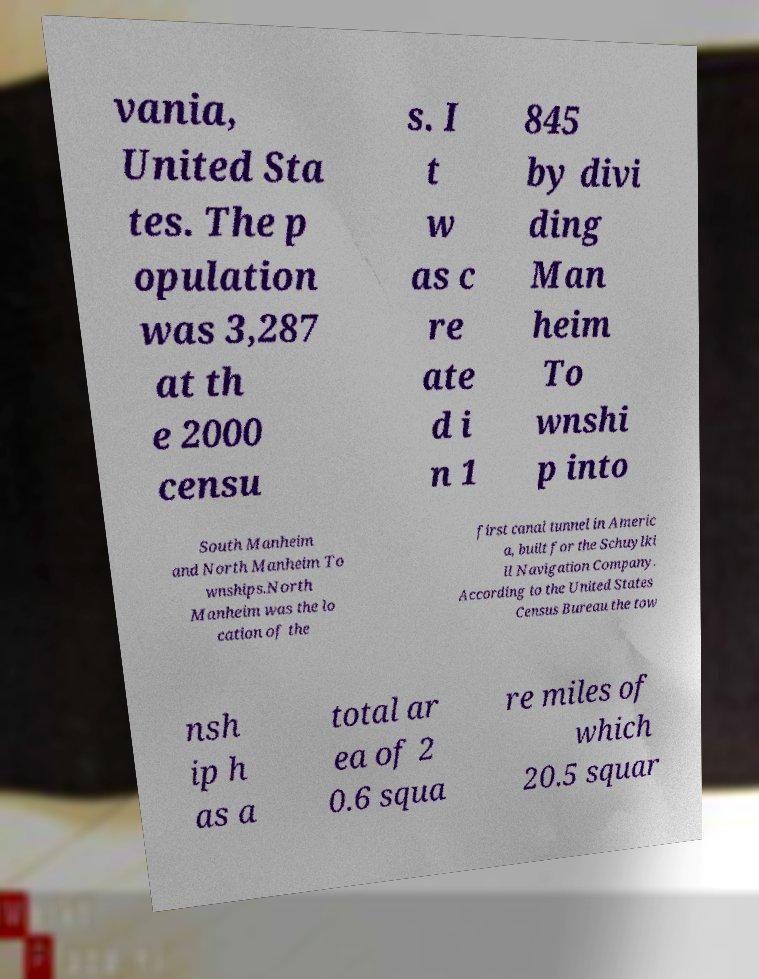Can you accurately transcribe the text from the provided image for me? vania, United Sta tes. The p opulation was 3,287 at th e 2000 censu s. I t w as c re ate d i n 1 845 by divi ding Man heim To wnshi p into South Manheim and North Manheim To wnships.North Manheim was the lo cation of the first canal tunnel in Americ a, built for the Schuylki ll Navigation Company. According to the United States Census Bureau the tow nsh ip h as a total ar ea of 2 0.6 squa re miles of which 20.5 squar 